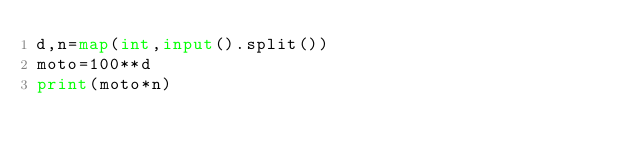<code> <loc_0><loc_0><loc_500><loc_500><_Python_>d,n=map(int,input().split())
moto=100**d
print(moto*n)</code> 